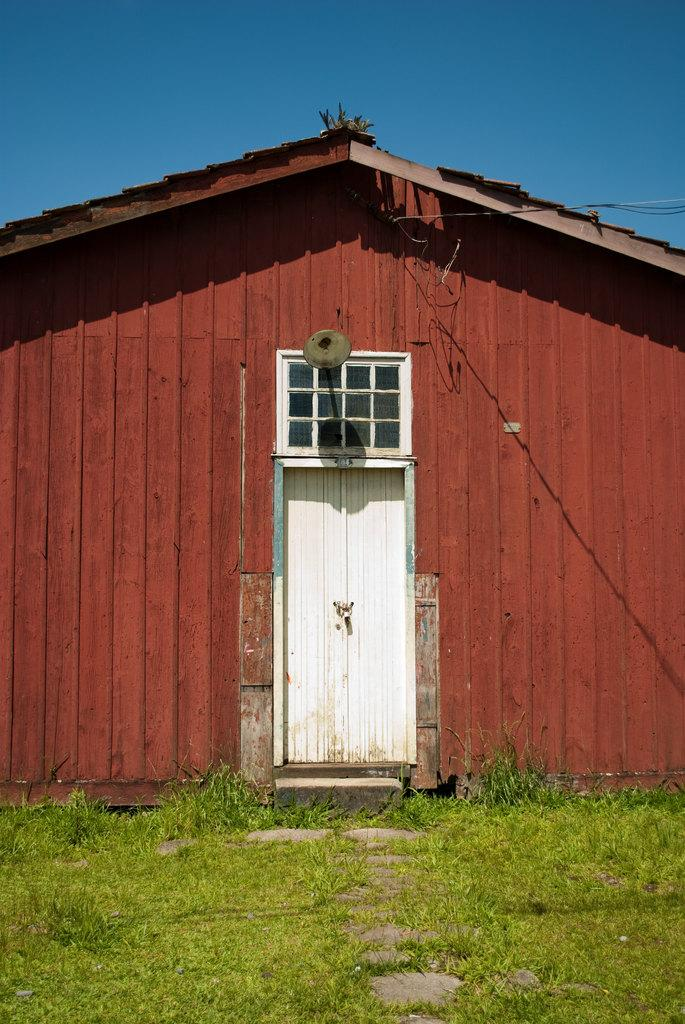What type of structure is visible in the image? There is a house in the image. What part of the house is visible in the image? There is a door in the image. What is visible at the top of the image? The sky is visible at the top of the image. What type of ground is present at the bottom of the image? Grass is present at the bottom of the image. Can you tell me how many rabbits are hopping on the grass in the image? There are no rabbits present in the image; only a house, a door, the sky, and grass are visible. 